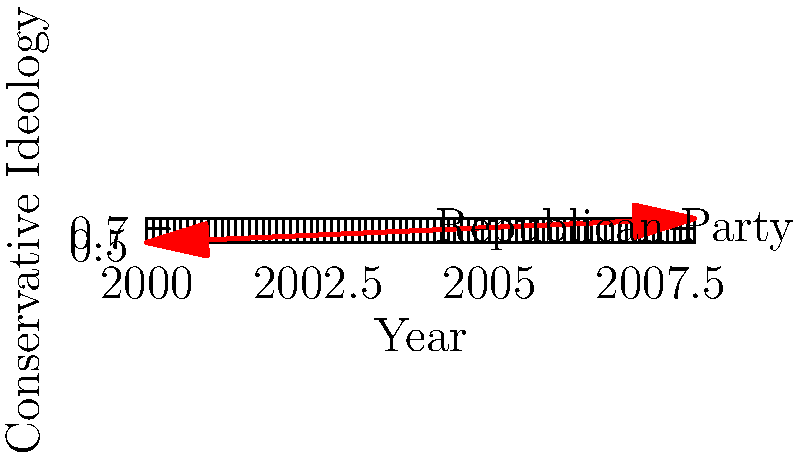Based on the vector diagram, how would you characterize the change in the Republican Party's ideological position from 2000 to 2008, considering the influence of the Bush administration's policies? To answer this question, let's analyze the vector diagram step-by-step:

1. The x-axis represents time, from 2000 to 2008, which corresponds to George W. Bush's presidency.

2. The y-axis represents the level of conservative ideology, with higher values indicating a more conservative stance.

3. The red arrow shows the trajectory of the Republican Party's ideological position over this period.

4. In 2000, the party's position starts at a moderate-conservative level (around 0.5 on the y-axis).

5. By 2008, the arrow points to a significantly higher position on the y-axis (around 0.85), indicating a strong rightward shift.

6. The steep upward slope of the arrow suggests a rapid and substantial move towards more conservative positions.

7. This shift coincides with the Bush administration's tenure, characterized by policies such as tax cuts, increased military spending, and conservative social policies.

8. From a liberal perspective, this rightward shift would be viewed negatively, as it represents a move away from more moderate or progressive policies.

9. The diagram suggests that the Republican Party became more aligned with hardline conservative ideology during this period, potentially alienating moderate voters and polarizing the political landscape.

Given this analysis, the change in the Republican Party's ideological position can be characterized as a significant rightward shift, moving towards more extreme conservative positions during the Bush administration.
Answer: Significant rightward shift 